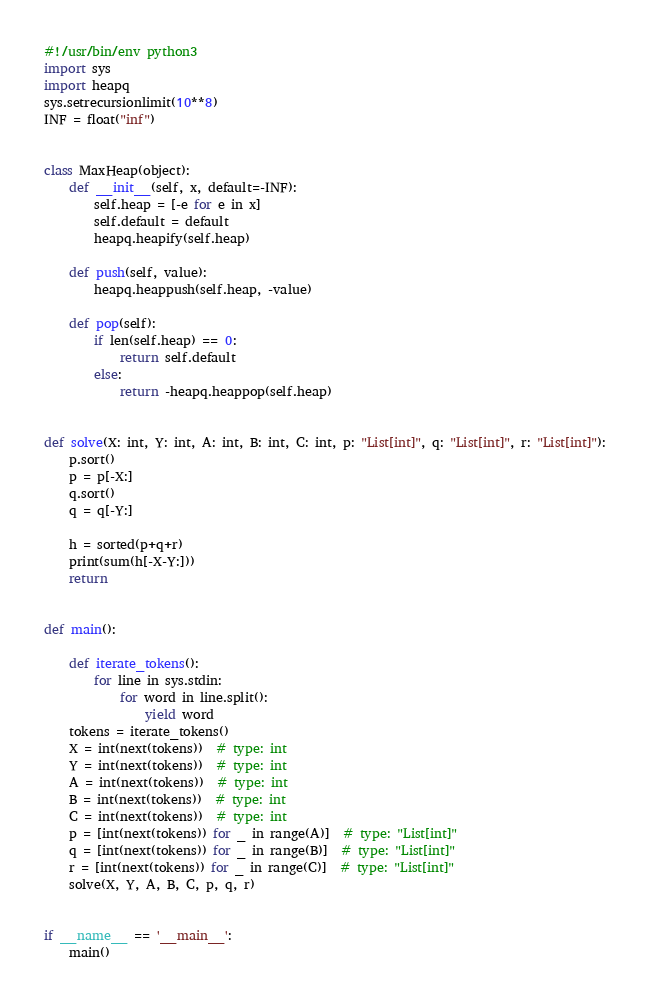Convert code to text. <code><loc_0><loc_0><loc_500><loc_500><_Python_>#!/usr/bin/env python3
import sys
import heapq
sys.setrecursionlimit(10**8)
INF = float("inf")


class MaxHeap(object):
    def __init__(self, x, default=-INF):
        self.heap = [-e for e in x]
        self.default = default
        heapq.heapify(self.heap)

    def push(self, value):
        heapq.heappush(self.heap, -value)

    def pop(self):
        if len(self.heap) == 0:
            return self.default
        else:
            return -heapq.heappop(self.heap)


def solve(X: int, Y: int, A: int, B: int, C: int, p: "List[int]", q: "List[int]", r: "List[int]"):
    p.sort()
    p = p[-X:]
    q.sort()
    q = q[-Y:]

    h = sorted(p+q+r)
    print(sum(h[-X-Y:]))
    return


def main():

    def iterate_tokens():
        for line in sys.stdin:
            for word in line.split():
                yield word
    tokens = iterate_tokens()
    X = int(next(tokens))  # type: int
    Y = int(next(tokens))  # type: int
    A = int(next(tokens))  # type: int
    B = int(next(tokens))  # type: int
    C = int(next(tokens))  # type: int
    p = [int(next(tokens)) for _ in range(A)]  # type: "List[int]"
    q = [int(next(tokens)) for _ in range(B)]  # type: "List[int]"
    r = [int(next(tokens)) for _ in range(C)]  # type: "List[int]"
    solve(X, Y, A, B, C, p, q, r)


if __name__ == '__main__':
    main()
</code> 